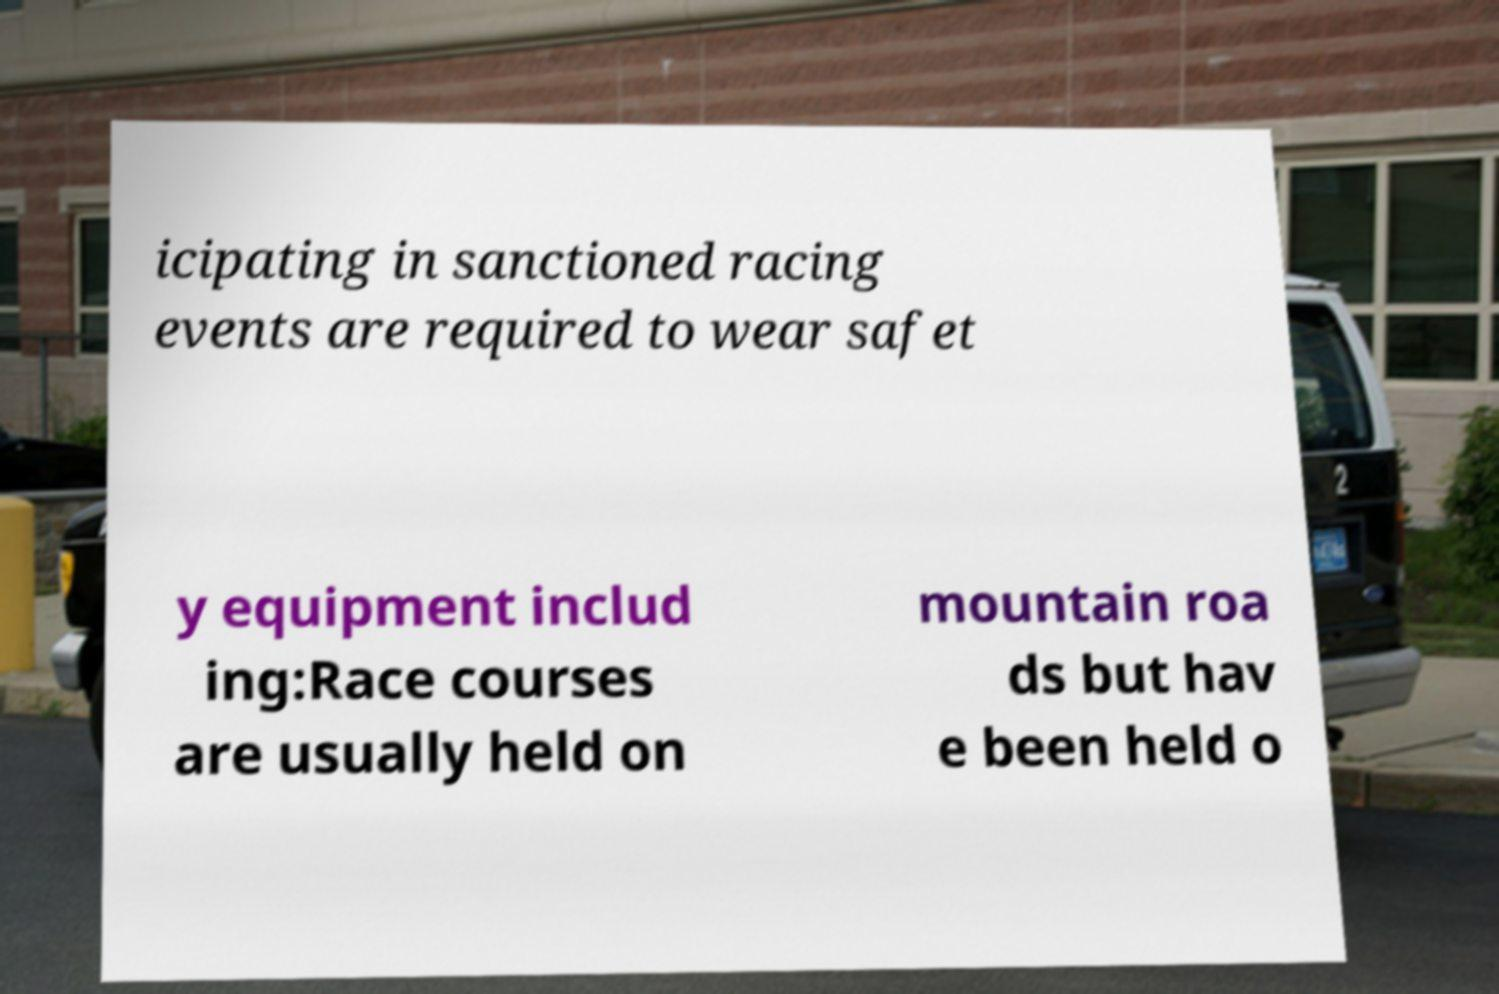Can you read and provide the text displayed in the image?This photo seems to have some interesting text. Can you extract and type it out for me? icipating in sanctioned racing events are required to wear safet y equipment includ ing:Race courses are usually held on mountain roa ds but hav e been held o 